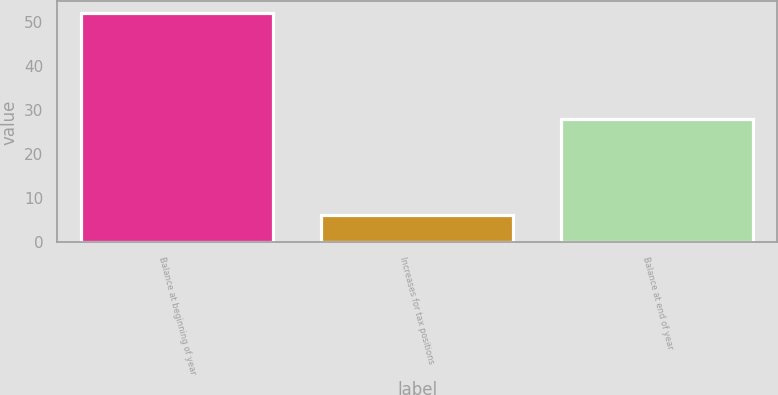<chart> <loc_0><loc_0><loc_500><loc_500><bar_chart><fcel>Balance at beginning of year<fcel>Increases for tax positions<fcel>Balance at end of year<nl><fcel>52<fcel>6.1<fcel>28<nl></chart> 